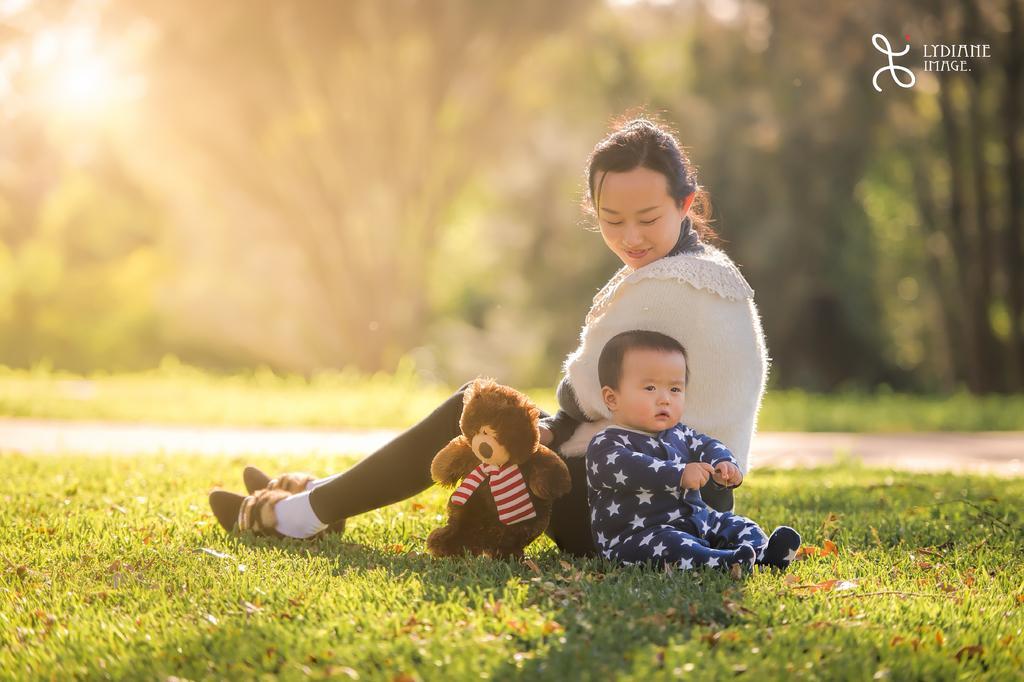Can you describe this image briefly? In the image there is a woman with shrug sitting on grass land along with a baby and teddy bear, in the back there are trees all over the image and on the left side there is sun. 